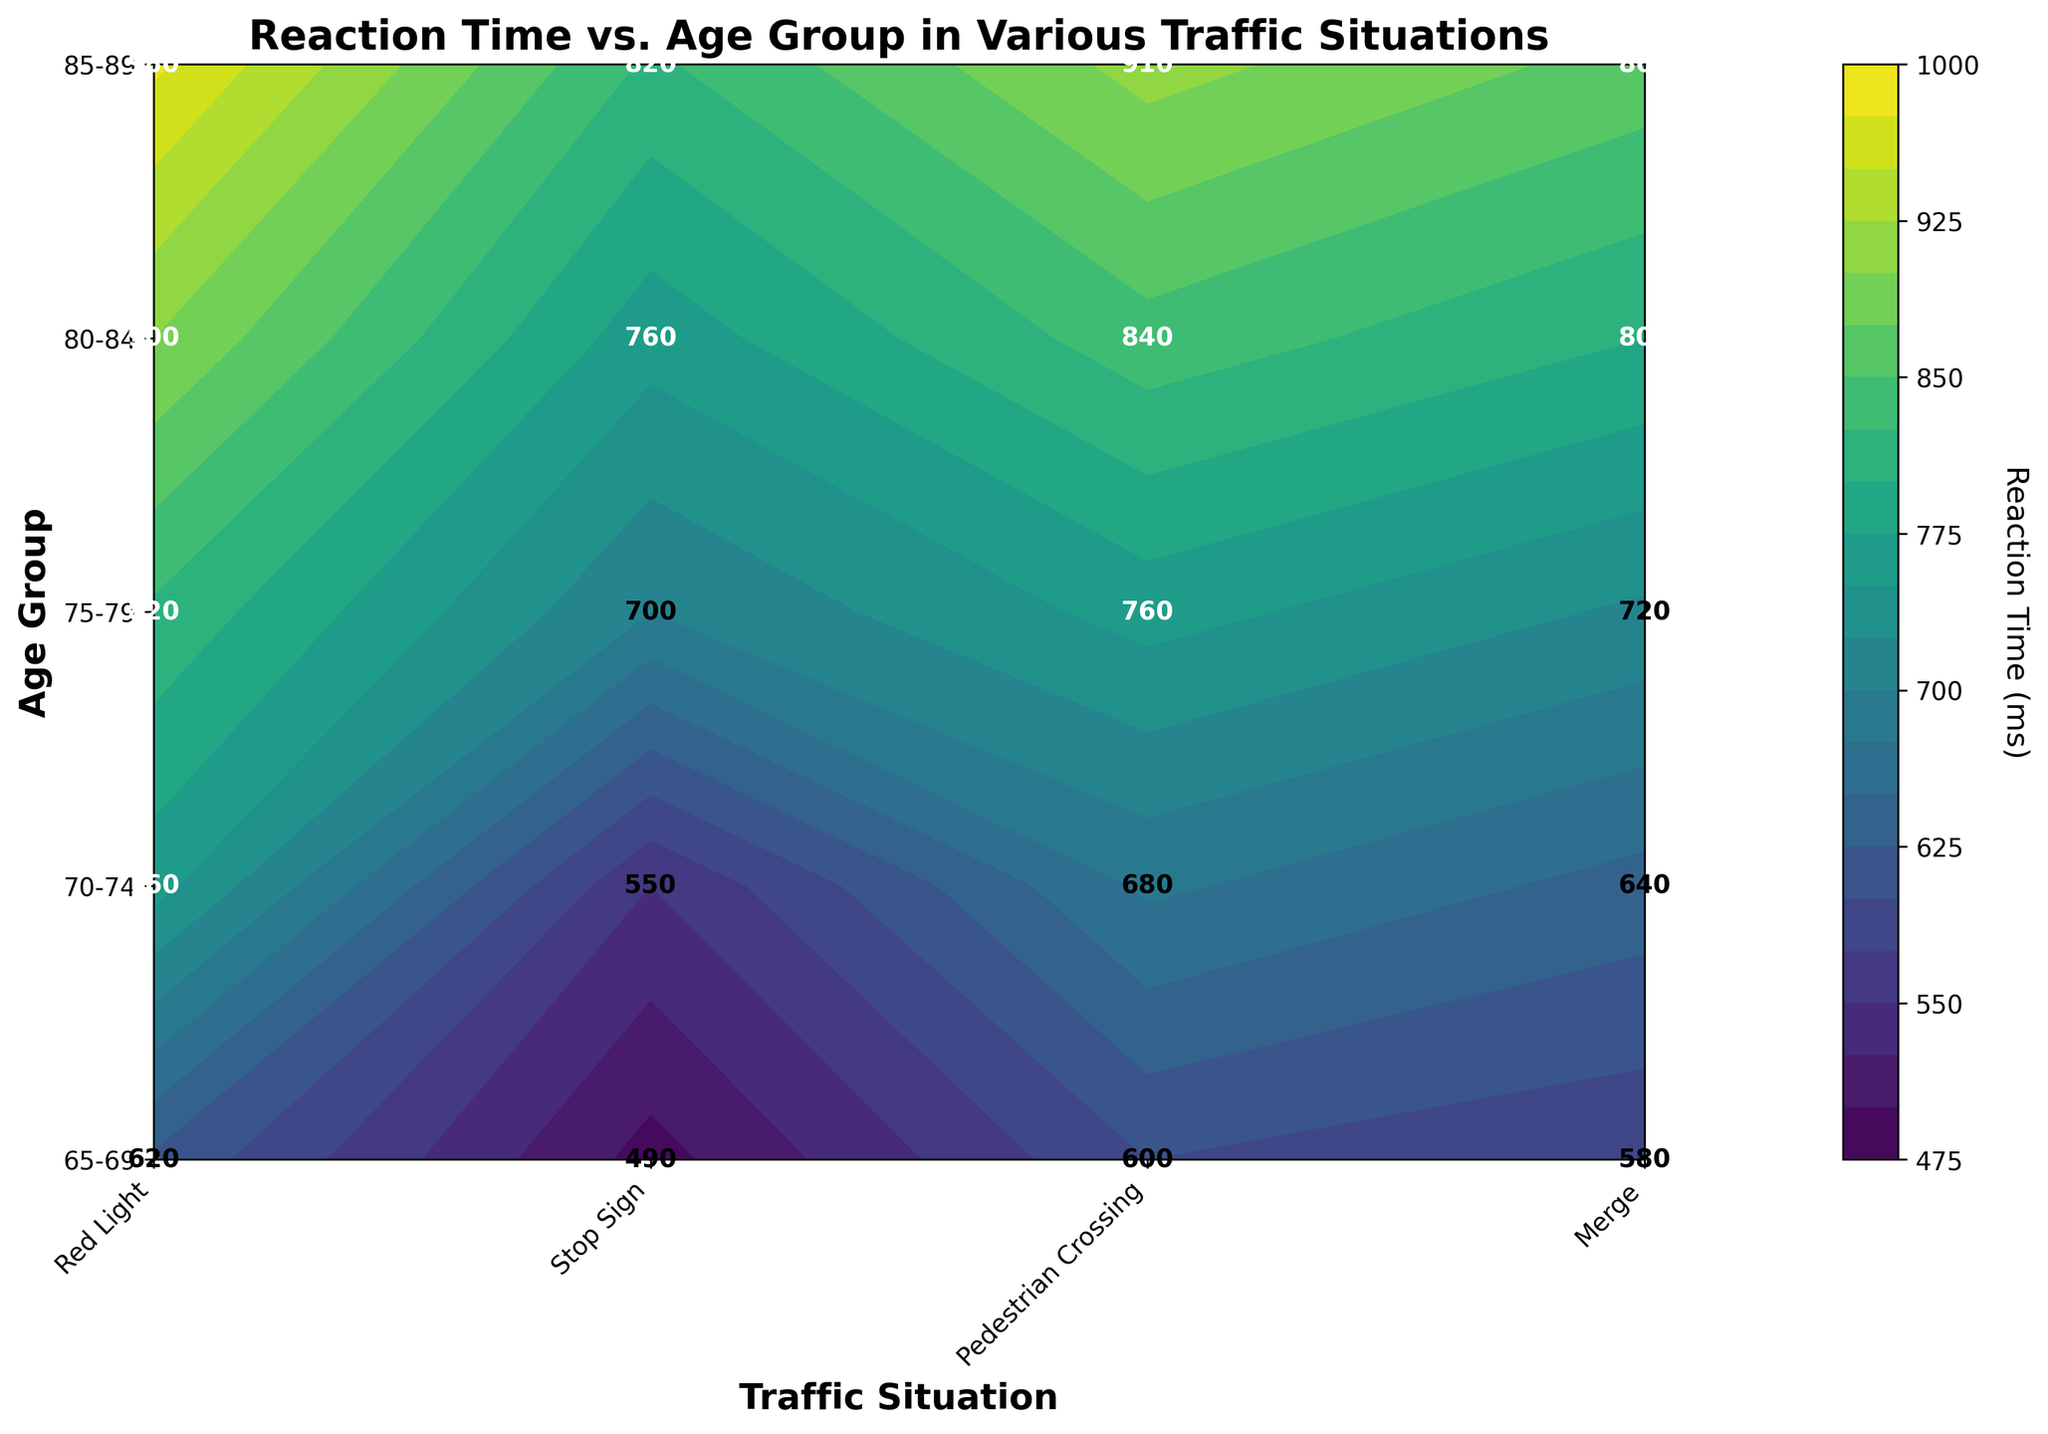What is the title of the figure? The title is the text located at the top center of the figure. Just read and interpret the graphical element.
Answer: Reaction Time vs. Age Group in Various Traffic Situations Which age group has the highest reaction time for "Merge" traffic situations? Look at the y-axis for age groups and locate the "Merge" column. Identify the age group with the highest value colored in the contour plot.
Answer: 85-89 What is the reaction time for the "Pedestrian Crossing" situation for the 75-79 age group? Locate the "Pedestrian Crossing" column and follow it up to the 75-79 age group row. The number at their intersection is your answer.
Answer: 700 ms How does the reaction time for "Stop Sign" situations change across age groups? Examine the "Stop Sign" column from the youngest to the oldest age group and observe the trend in the contour plot.
Answer: It increases with age Compare the reaction times for the "Red Light" situation between the 65-69 and 85-89 age groups. Which is higher and by how much? List the reaction times for the two age groups (600 ms and 910 ms) and subtract them (910 - 600). Determine which is higher.
Answer: 85-89 by 310 ms What is the average reaction time for the "Merge" situation across all age groups? Extract reaction times for the "Merge" situation (620, 760, 820, 900, 980). Sum them and divide by the number of values (sum = 4080, values = 5).
Answer: 816 ms Which traffic situation has the lowest reaction time for the 70-74 age group? Look at the 70-74 age group row and identify the column with the smallest number.
Answer: Pedestrian Crossing What can be inferred about the reaction time's trend as age increases for "Red Light" traffic situations? Examine the "Red Light" column from youngest to oldest age groups and describe the trend seen in the contour plot.
Answer: Increases with age 